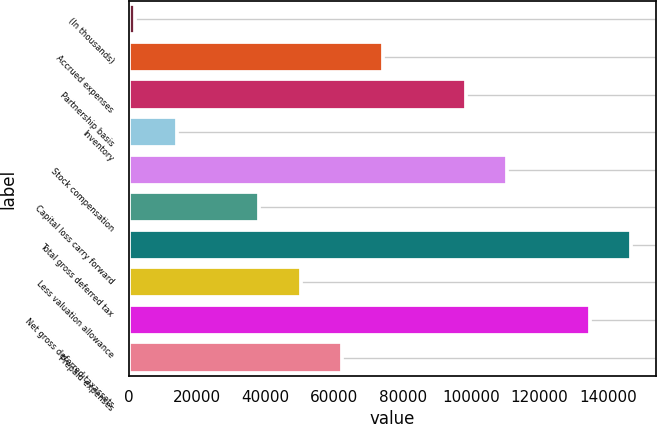Convert chart. <chart><loc_0><loc_0><loc_500><loc_500><bar_chart><fcel>(In thousands)<fcel>Accrued expenses<fcel>Partnership basis<fcel>Inventory<fcel>Stock compensation<fcel>Capital loss carry forward<fcel>Total gross deferred tax<fcel>Less valuation allowance<fcel>Net gross deferred taxassets<fcel>Prepaid expenses<nl><fcel>2009<fcel>74302.4<fcel>98400.2<fcel>14057.9<fcel>110449<fcel>38155.7<fcel>146596<fcel>50204.6<fcel>134547<fcel>62253.5<nl></chart> 